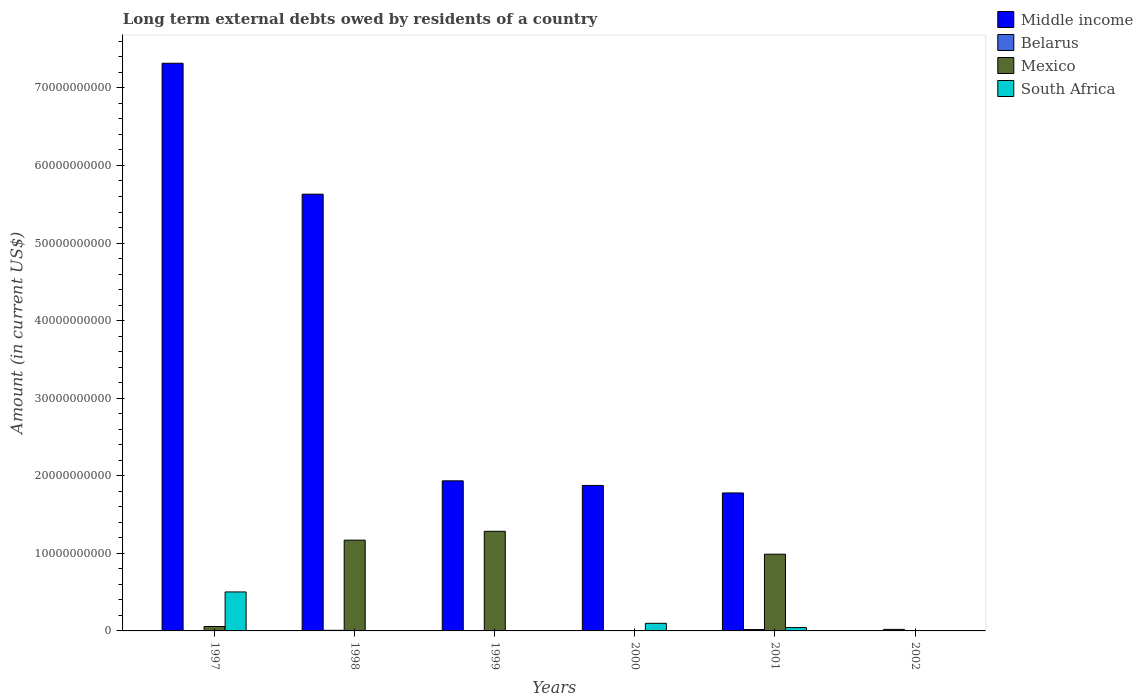Are the number of bars per tick equal to the number of legend labels?
Your answer should be compact. No. How many bars are there on the 5th tick from the left?
Your response must be concise. 4. How many bars are there on the 1st tick from the right?
Ensure brevity in your answer.  1. In how many cases, is the number of bars for a given year not equal to the number of legend labels?
Provide a succinct answer. 4. What is the amount of long-term external debts owed by residents in Mexico in 1999?
Your response must be concise. 1.28e+1. Across all years, what is the maximum amount of long-term external debts owed by residents in Belarus?
Ensure brevity in your answer.  1.99e+08. What is the total amount of long-term external debts owed by residents in Middle income in the graph?
Your answer should be very brief. 1.85e+11. What is the difference between the amount of long-term external debts owed by residents in Middle income in 1998 and that in 2000?
Provide a succinct answer. 3.75e+1. What is the difference between the amount of long-term external debts owed by residents in Belarus in 1997 and the amount of long-term external debts owed by residents in Middle income in 1999?
Offer a terse response. -1.93e+1. What is the average amount of long-term external debts owed by residents in Belarus per year?
Keep it short and to the point. 8.48e+07. In the year 1998, what is the difference between the amount of long-term external debts owed by residents in Mexico and amount of long-term external debts owed by residents in Middle income?
Make the answer very short. -4.46e+1. In how many years, is the amount of long-term external debts owed by residents in Belarus greater than 42000000000 US$?
Make the answer very short. 0. What is the ratio of the amount of long-term external debts owed by residents in Middle income in 1998 to that in 1999?
Offer a terse response. 2.91. Is the amount of long-term external debts owed by residents in Mexico in 1998 less than that in 1999?
Keep it short and to the point. Yes. What is the difference between the highest and the second highest amount of long-term external debts owed by residents in South Africa?
Your answer should be compact. 4.04e+09. What is the difference between the highest and the lowest amount of long-term external debts owed by residents in Mexico?
Your answer should be compact. 1.28e+1. Is the sum of the amount of long-term external debts owed by residents in South Africa in 2000 and 2001 greater than the maximum amount of long-term external debts owed by residents in Belarus across all years?
Your response must be concise. Yes. Is it the case that in every year, the sum of the amount of long-term external debts owed by residents in Middle income and amount of long-term external debts owed by residents in Belarus is greater than the amount of long-term external debts owed by residents in South Africa?
Provide a succinct answer. Yes. How many bars are there?
Ensure brevity in your answer.  17. Are all the bars in the graph horizontal?
Offer a terse response. No. How many years are there in the graph?
Provide a short and direct response. 6. Are the values on the major ticks of Y-axis written in scientific E-notation?
Give a very brief answer. No. Does the graph contain any zero values?
Make the answer very short. Yes. Where does the legend appear in the graph?
Ensure brevity in your answer.  Top right. How are the legend labels stacked?
Give a very brief answer. Vertical. What is the title of the graph?
Provide a short and direct response. Long term external debts owed by residents of a country. Does "Channel Islands" appear as one of the legend labels in the graph?
Your response must be concise. No. What is the label or title of the X-axis?
Make the answer very short. Years. What is the label or title of the Y-axis?
Your answer should be very brief. Amount (in current US$). What is the Amount (in current US$) in Middle income in 1997?
Offer a very short reply. 7.32e+1. What is the Amount (in current US$) in Belarus in 1997?
Offer a very short reply. 7.89e+06. What is the Amount (in current US$) in Mexico in 1997?
Offer a very short reply. 5.69e+08. What is the Amount (in current US$) of South Africa in 1997?
Provide a succinct answer. 5.02e+09. What is the Amount (in current US$) in Middle income in 1998?
Provide a short and direct response. 5.63e+1. What is the Amount (in current US$) in Belarus in 1998?
Keep it short and to the point. 8.03e+07. What is the Amount (in current US$) of Mexico in 1998?
Provide a succinct answer. 1.17e+1. What is the Amount (in current US$) of South Africa in 1998?
Give a very brief answer. 0. What is the Amount (in current US$) of Middle income in 1999?
Keep it short and to the point. 1.93e+1. What is the Amount (in current US$) in Mexico in 1999?
Provide a succinct answer. 1.28e+1. What is the Amount (in current US$) in South Africa in 1999?
Offer a very short reply. 0. What is the Amount (in current US$) in Middle income in 2000?
Give a very brief answer. 1.88e+1. What is the Amount (in current US$) in Belarus in 2000?
Provide a succinct answer. 4.45e+07. What is the Amount (in current US$) of South Africa in 2000?
Your response must be concise. 9.80e+08. What is the Amount (in current US$) in Middle income in 2001?
Give a very brief answer. 1.78e+1. What is the Amount (in current US$) in Belarus in 2001?
Your answer should be very brief. 1.77e+08. What is the Amount (in current US$) in Mexico in 2001?
Provide a succinct answer. 9.89e+09. What is the Amount (in current US$) of South Africa in 2001?
Your answer should be compact. 4.31e+08. What is the Amount (in current US$) of Belarus in 2002?
Offer a very short reply. 1.99e+08. What is the Amount (in current US$) of Mexico in 2002?
Ensure brevity in your answer.  0. Across all years, what is the maximum Amount (in current US$) of Middle income?
Offer a terse response. 7.32e+1. Across all years, what is the maximum Amount (in current US$) of Belarus?
Keep it short and to the point. 1.99e+08. Across all years, what is the maximum Amount (in current US$) in Mexico?
Provide a short and direct response. 1.28e+1. Across all years, what is the maximum Amount (in current US$) of South Africa?
Make the answer very short. 5.02e+09. Across all years, what is the minimum Amount (in current US$) of Middle income?
Your answer should be very brief. 0. What is the total Amount (in current US$) of Middle income in the graph?
Keep it short and to the point. 1.85e+11. What is the total Amount (in current US$) of Belarus in the graph?
Your response must be concise. 5.09e+08. What is the total Amount (in current US$) in Mexico in the graph?
Provide a succinct answer. 3.50e+1. What is the total Amount (in current US$) in South Africa in the graph?
Provide a short and direct response. 6.44e+09. What is the difference between the Amount (in current US$) of Middle income in 1997 and that in 1998?
Provide a succinct answer. 1.69e+1. What is the difference between the Amount (in current US$) in Belarus in 1997 and that in 1998?
Keep it short and to the point. -7.24e+07. What is the difference between the Amount (in current US$) of Mexico in 1997 and that in 1998?
Ensure brevity in your answer.  -1.11e+1. What is the difference between the Amount (in current US$) in Middle income in 1997 and that in 1999?
Provide a succinct answer. 5.38e+1. What is the difference between the Amount (in current US$) in Mexico in 1997 and that in 1999?
Keep it short and to the point. -1.23e+1. What is the difference between the Amount (in current US$) in Middle income in 1997 and that in 2000?
Offer a very short reply. 5.44e+1. What is the difference between the Amount (in current US$) in Belarus in 1997 and that in 2000?
Ensure brevity in your answer.  -3.66e+07. What is the difference between the Amount (in current US$) of South Africa in 1997 and that in 2000?
Offer a terse response. 4.04e+09. What is the difference between the Amount (in current US$) in Middle income in 1997 and that in 2001?
Keep it short and to the point. 5.54e+1. What is the difference between the Amount (in current US$) of Belarus in 1997 and that in 2001?
Keep it short and to the point. -1.70e+08. What is the difference between the Amount (in current US$) in Mexico in 1997 and that in 2001?
Give a very brief answer. -9.32e+09. What is the difference between the Amount (in current US$) in South Africa in 1997 and that in 2001?
Offer a terse response. 4.59e+09. What is the difference between the Amount (in current US$) in Belarus in 1997 and that in 2002?
Keep it short and to the point. -1.91e+08. What is the difference between the Amount (in current US$) in Middle income in 1998 and that in 1999?
Keep it short and to the point. 3.70e+1. What is the difference between the Amount (in current US$) of Mexico in 1998 and that in 1999?
Offer a very short reply. -1.14e+09. What is the difference between the Amount (in current US$) of Middle income in 1998 and that in 2000?
Your response must be concise. 3.75e+1. What is the difference between the Amount (in current US$) of Belarus in 1998 and that in 2000?
Offer a terse response. 3.58e+07. What is the difference between the Amount (in current US$) of Middle income in 1998 and that in 2001?
Keep it short and to the point. 3.85e+1. What is the difference between the Amount (in current US$) of Belarus in 1998 and that in 2001?
Offer a terse response. -9.72e+07. What is the difference between the Amount (in current US$) in Mexico in 1998 and that in 2001?
Give a very brief answer. 1.81e+09. What is the difference between the Amount (in current US$) in Belarus in 1998 and that in 2002?
Offer a very short reply. -1.18e+08. What is the difference between the Amount (in current US$) in Middle income in 1999 and that in 2000?
Offer a very short reply. 5.97e+08. What is the difference between the Amount (in current US$) of Middle income in 1999 and that in 2001?
Provide a succinct answer. 1.56e+09. What is the difference between the Amount (in current US$) of Mexico in 1999 and that in 2001?
Give a very brief answer. 2.95e+09. What is the difference between the Amount (in current US$) in Middle income in 2000 and that in 2001?
Offer a terse response. 9.65e+08. What is the difference between the Amount (in current US$) of Belarus in 2000 and that in 2001?
Your response must be concise. -1.33e+08. What is the difference between the Amount (in current US$) of South Africa in 2000 and that in 2001?
Keep it short and to the point. 5.50e+08. What is the difference between the Amount (in current US$) of Belarus in 2000 and that in 2002?
Your answer should be very brief. -1.54e+08. What is the difference between the Amount (in current US$) in Belarus in 2001 and that in 2002?
Keep it short and to the point. -2.11e+07. What is the difference between the Amount (in current US$) of Middle income in 1997 and the Amount (in current US$) of Belarus in 1998?
Keep it short and to the point. 7.31e+1. What is the difference between the Amount (in current US$) in Middle income in 1997 and the Amount (in current US$) in Mexico in 1998?
Provide a succinct answer. 6.15e+1. What is the difference between the Amount (in current US$) of Belarus in 1997 and the Amount (in current US$) of Mexico in 1998?
Keep it short and to the point. -1.17e+1. What is the difference between the Amount (in current US$) of Middle income in 1997 and the Amount (in current US$) of Mexico in 1999?
Provide a succinct answer. 6.03e+1. What is the difference between the Amount (in current US$) of Belarus in 1997 and the Amount (in current US$) of Mexico in 1999?
Make the answer very short. -1.28e+1. What is the difference between the Amount (in current US$) of Middle income in 1997 and the Amount (in current US$) of Belarus in 2000?
Offer a very short reply. 7.31e+1. What is the difference between the Amount (in current US$) of Middle income in 1997 and the Amount (in current US$) of South Africa in 2000?
Your answer should be very brief. 7.22e+1. What is the difference between the Amount (in current US$) in Belarus in 1997 and the Amount (in current US$) in South Africa in 2000?
Offer a very short reply. -9.72e+08. What is the difference between the Amount (in current US$) of Mexico in 1997 and the Amount (in current US$) of South Africa in 2000?
Give a very brief answer. -4.12e+08. What is the difference between the Amount (in current US$) in Middle income in 1997 and the Amount (in current US$) in Belarus in 2001?
Make the answer very short. 7.30e+1. What is the difference between the Amount (in current US$) in Middle income in 1997 and the Amount (in current US$) in Mexico in 2001?
Provide a short and direct response. 6.33e+1. What is the difference between the Amount (in current US$) of Middle income in 1997 and the Amount (in current US$) of South Africa in 2001?
Give a very brief answer. 7.27e+1. What is the difference between the Amount (in current US$) of Belarus in 1997 and the Amount (in current US$) of Mexico in 2001?
Keep it short and to the point. -9.88e+09. What is the difference between the Amount (in current US$) in Belarus in 1997 and the Amount (in current US$) in South Africa in 2001?
Your answer should be very brief. -4.23e+08. What is the difference between the Amount (in current US$) in Mexico in 1997 and the Amount (in current US$) in South Africa in 2001?
Your answer should be very brief. 1.38e+08. What is the difference between the Amount (in current US$) in Middle income in 1997 and the Amount (in current US$) in Belarus in 2002?
Provide a short and direct response. 7.30e+1. What is the difference between the Amount (in current US$) in Middle income in 1998 and the Amount (in current US$) in Mexico in 1999?
Your answer should be very brief. 4.35e+1. What is the difference between the Amount (in current US$) in Belarus in 1998 and the Amount (in current US$) in Mexico in 1999?
Provide a short and direct response. -1.28e+1. What is the difference between the Amount (in current US$) of Middle income in 1998 and the Amount (in current US$) of Belarus in 2000?
Ensure brevity in your answer.  5.63e+1. What is the difference between the Amount (in current US$) in Middle income in 1998 and the Amount (in current US$) in South Africa in 2000?
Your answer should be compact. 5.53e+1. What is the difference between the Amount (in current US$) of Belarus in 1998 and the Amount (in current US$) of South Africa in 2000?
Your answer should be very brief. -9.00e+08. What is the difference between the Amount (in current US$) of Mexico in 1998 and the Amount (in current US$) of South Africa in 2000?
Your answer should be compact. 1.07e+1. What is the difference between the Amount (in current US$) in Middle income in 1998 and the Amount (in current US$) in Belarus in 2001?
Offer a terse response. 5.61e+1. What is the difference between the Amount (in current US$) of Middle income in 1998 and the Amount (in current US$) of Mexico in 2001?
Your answer should be very brief. 4.64e+1. What is the difference between the Amount (in current US$) in Middle income in 1998 and the Amount (in current US$) in South Africa in 2001?
Ensure brevity in your answer.  5.59e+1. What is the difference between the Amount (in current US$) of Belarus in 1998 and the Amount (in current US$) of Mexico in 2001?
Offer a very short reply. -9.81e+09. What is the difference between the Amount (in current US$) in Belarus in 1998 and the Amount (in current US$) in South Africa in 2001?
Provide a succinct answer. -3.50e+08. What is the difference between the Amount (in current US$) of Mexico in 1998 and the Amount (in current US$) of South Africa in 2001?
Ensure brevity in your answer.  1.13e+1. What is the difference between the Amount (in current US$) of Middle income in 1998 and the Amount (in current US$) of Belarus in 2002?
Ensure brevity in your answer.  5.61e+1. What is the difference between the Amount (in current US$) in Middle income in 1999 and the Amount (in current US$) in Belarus in 2000?
Keep it short and to the point. 1.93e+1. What is the difference between the Amount (in current US$) in Middle income in 1999 and the Amount (in current US$) in South Africa in 2000?
Give a very brief answer. 1.84e+1. What is the difference between the Amount (in current US$) of Mexico in 1999 and the Amount (in current US$) of South Africa in 2000?
Provide a short and direct response. 1.19e+1. What is the difference between the Amount (in current US$) of Middle income in 1999 and the Amount (in current US$) of Belarus in 2001?
Offer a terse response. 1.92e+1. What is the difference between the Amount (in current US$) in Middle income in 1999 and the Amount (in current US$) in Mexico in 2001?
Make the answer very short. 9.46e+09. What is the difference between the Amount (in current US$) in Middle income in 1999 and the Amount (in current US$) in South Africa in 2001?
Provide a succinct answer. 1.89e+1. What is the difference between the Amount (in current US$) of Mexico in 1999 and the Amount (in current US$) of South Africa in 2001?
Provide a short and direct response. 1.24e+1. What is the difference between the Amount (in current US$) in Middle income in 1999 and the Amount (in current US$) in Belarus in 2002?
Provide a short and direct response. 1.91e+1. What is the difference between the Amount (in current US$) of Middle income in 2000 and the Amount (in current US$) of Belarus in 2001?
Your answer should be compact. 1.86e+1. What is the difference between the Amount (in current US$) of Middle income in 2000 and the Amount (in current US$) of Mexico in 2001?
Ensure brevity in your answer.  8.86e+09. What is the difference between the Amount (in current US$) of Middle income in 2000 and the Amount (in current US$) of South Africa in 2001?
Your answer should be compact. 1.83e+1. What is the difference between the Amount (in current US$) of Belarus in 2000 and the Amount (in current US$) of Mexico in 2001?
Offer a terse response. -9.85e+09. What is the difference between the Amount (in current US$) in Belarus in 2000 and the Amount (in current US$) in South Africa in 2001?
Provide a succinct answer. -3.86e+08. What is the difference between the Amount (in current US$) of Middle income in 2000 and the Amount (in current US$) of Belarus in 2002?
Offer a terse response. 1.86e+1. What is the difference between the Amount (in current US$) in Middle income in 2001 and the Amount (in current US$) in Belarus in 2002?
Keep it short and to the point. 1.76e+1. What is the average Amount (in current US$) in Middle income per year?
Make the answer very short. 3.09e+1. What is the average Amount (in current US$) of Belarus per year?
Offer a terse response. 8.48e+07. What is the average Amount (in current US$) in Mexico per year?
Provide a succinct answer. 5.83e+09. What is the average Amount (in current US$) of South Africa per year?
Keep it short and to the point. 1.07e+09. In the year 1997, what is the difference between the Amount (in current US$) of Middle income and Amount (in current US$) of Belarus?
Your response must be concise. 7.32e+1. In the year 1997, what is the difference between the Amount (in current US$) in Middle income and Amount (in current US$) in Mexico?
Make the answer very short. 7.26e+1. In the year 1997, what is the difference between the Amount (in current US$) of Middle income and Amount (in current US$) of South Africa?
Offer a terse response. 6.82e+1. In the year 1997, what is the difference between the Amount (in current US$) of Belarus and Amount (in current US$) of Mexico?
Ensure brevity in your answer.  -5.61e+08. In the year 1997, what is the difference between the Amount (in current US$) of Belarus and Amount (in current US$) of South Africa?
Keep it short and to the point. -5.02e+09. In the year 1997, what is the difference between the Amount (in current US$) of Mexico and Amount (in current US$) of South Africa?
Make the answer very short. -4.46e+09. In the year 1998, what is the difference between the Amount (in current US$) in Middle income and Amount (in current US$) in Belarus?
Offer a very short reply. 5.62e+1. In the year 1998, what is the difference between the Amount (in current US$) in Middle income and Amount (in current US$) in Mexico?
Offer a terse response. 4.46e+1. In the year 1998, what is the difference between the Amount (in current US$) of Belarus and Amount (in current US$) of Mexico?
Give a very brief answer. -1.16e+1. In the year 1999, what is the difference between the Amount (in current US$) of Middle income and Amount (in current US$) of Mexico?
Provide a succinct answer. 6.50e+09. In the year 2000, what is the difference between the Amount (in current US$) in Middle income and Amount (in current US$) in Belarus?
Your response must be concise. 1.87e+1. In the year 2000, what is the difference between the Amount (in current US$) in Middle income and Amount (in current US$) in South Africa?
Provide a succinct answer. 1.78e+1. In the year 2000, what is the difference between the Amount (in current US$) in Belarus and Amount (in current US$) in South Africa?
Your response must be concise. -9.36e+08. In the year 2001, what is the difference between the Amount (in current US$) in Middle income and Amount (in current US$) in Belarus?
Keep it short and to the point. 1.76e+1. In the year 2001, what is the difference between the Amount (in current US$) of Middle income and Amount (in current US$) of Mexico?
Offer a terse response. 7.89e+09. In the year 2001, what is the difference between the Amount (in current US$) of Middle income and Amount (in current US$) of South Africa?
Provide a succinct answer. 1.74e+1. In the year 2001, what is the difference between the Amount (in current US$) in Belarus and Amount (in current US$) in Mexico?
Make the answer very short. -9.71e+09. In the year 2001, what is the difference between the Amount (in current US$) in Belarus and Amount (in current US$) in South Africa?
Keep it short and to the point. -2.53e+08. In the year 2001, what is the difference between the Amount (in current US$) of Mexico and Amount (in current US$) of South Africa?
Make the answer very short. 9.46e+09. What is the ratio of the Amount (in current US$) in Middle income in 1997 to that in 1998?
Offer a very short reply. 1.3. What is the ratio of the Amount (in current US$) in Belarus in 1997 to that in 1998?
Provide a short and direct response. 0.1. What is the ratio of the Amount (in current US$) of Mexico in 1997 to that in 1998?
Give a very brief answer. 0.05. What is the ratio of the Amount (in current US$) in Middle income in 1997 to that in 1999?
Your response must be concise. 3.78. What is the ratio of the Amount (in current US$) in Mexico in 1997 to that in 1999?
Give a very brief answer. 0.04. What is the ratio of the Amount (in current US$) in Middle income in 1997 to that in 2000?
Your response must be concise. 3.9. What is the ratio of the Amount (in current US$) in Belarus in 1997 to that in 2000?
Your response must be concise. 0.18. What is the ratio of the Amount (in current US$) in South Africa in 1997 to that in 2000?
Make the answer very short. 5.13. What is the ratio of the Amount (in current US$) in Middle income in 1997 to that in 2001?
Offer a very short reply. 4.11. What is the ratio of the Amount (in current US$) in Belarus in 1997 to that in 2001?
Your answer should be very brief. 0.04. What is the ratio of the Amount (in current US$) in Mexico in 1997 to that in 2001?
Your answer should be compact. 0.06. What is the ratio of the Amount (in current US$) of South Africa in 1997 to that in 2001?
Your response must be concise. 11.66. What is the ratio of the Amount (in current US$) of Belarus in 1997 to that in 2002?
Give a very brief answer. 0.04. What is the ratio of the Amount (in current US$) in Middle income in 1998 to that in 1999?
Provide a short and direct response. 2.91. What is the ratio of the Amount (in current US$) of Mexico in 1998 to that in 1999?
Give a very brief answer. 0.91. What is the ratio of the Amount (in current US$) of Middle income in 1998 to that in 2000?
Give a very brief answer. 3. What is the ratio of the Amount (in current US$) in Belarus in 1998 to that in 2000?
Provide a short and direct response. 1.81. What is the ratio of the Amount (in current US$) of Middle income in 1998 to that in 2001?
Your response must be concise. 3.17. What is the ratio of the Amount (in current US$) in Belarus in 1998 to that in 2001?
Give a very brief answer. 0.45. What is the ratio of the Amount (in current US$) in Mexico in 1998 to that in 2001?
Your response must be concise. 1.18. What is the ratio of the Amount (in current US$) of Belarus in 1998 to that in 2002?
Provide a succinct answer. 0.4. What is the ratio of the Amount (in current US$) in Middle income in 1999 to that in 2000?
Offer a terse response. 1.03. What is the ratio of the Amount (in current US$) of Middle income in 1999 to that in 2001?
Ensure brevity in your answer.  1.09. What is the ratio of the Amount (in current US$) of Mexico in 1999 to that in 2001?
Provide a short and direct response. 1.3. What is the ratio of the Amount (in current US$) in Middle income in 2000 to that in 2001?
Your answer should be compact. 1.05. What is the ratio of the Amount (in current US$) of Belarus in 2000 to that in 2001?
Offer a terse response. 0.25. What is the ratio of the Amount (in current US$) of South Africa in 2000 to that in 2001?
Keep it short and to the point. 2.28. What is the ratio of the Amount (in current US$) of Belarus in 2000 to that in 2002?
Your answer should be compact. 0.22. What is the ratio of the Amount (in current US$) of Belarus in 2001 to that in 2002?
Provide a succinct answer. 0.89. What is the difference between the highest and the second highest Amount (in current US$) of Middle income?
Ensure brevity in your answer.  1.69e+1. What is the difference between the highest and the second highest Amount (in current US$) in Belarus?
Give a very brief answer. 2.11e+07. What is the difference between the highest and the second highest Amount (in current US$) of Mexico?
Keep it short and to the point. 1.14e+09. What is the difference between the highest and the second highest Amount (in current US$) in South Africa?
Your answer should be compact. 4.04e+09. What is the difference between the highest and the lowest Amount (in current US$) of Middle income?
Make the answer very short. 7.32e+1. What is the difference between the highest and the lowest Amount (in current US$) of Belarus?
Provide a short and direct response. 1.99e+08. What is the difference between the highest and the lowest Amount (in current US$) in Mexico?
Give a very brief answer. 1.28e+1. What is the difference between the highest and the lowest Amount (in current US$) of South Africa?
Provide a succinct answer. 5.02e+09. 